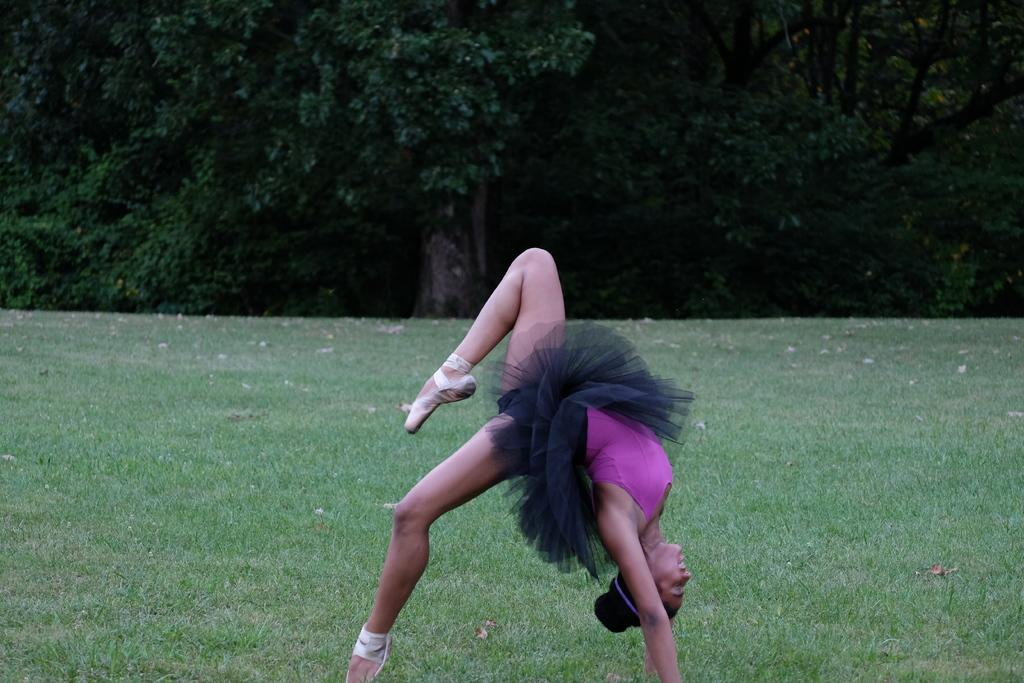What is the main subject of the image? The main subject of the image is a woman. What is the woman doing in the image? The woman is performing gymnastics in the image. What type of surface is the woman performing gymnastics on? There is grass on the ground in the image. What can be seen in the background of the image? Trees are visible in the image. What color is the dress the woman is wearing? The woman is wearing a pink and black color dress. What type of house can be seen in the background of the image? There is no house visible in the background of the image; only trees are present. What type of apparatus is the woman using to perform gymnastics in the image? The image does not show the woman using any specific apparatus for gymnastics; she is performing on the grass. 